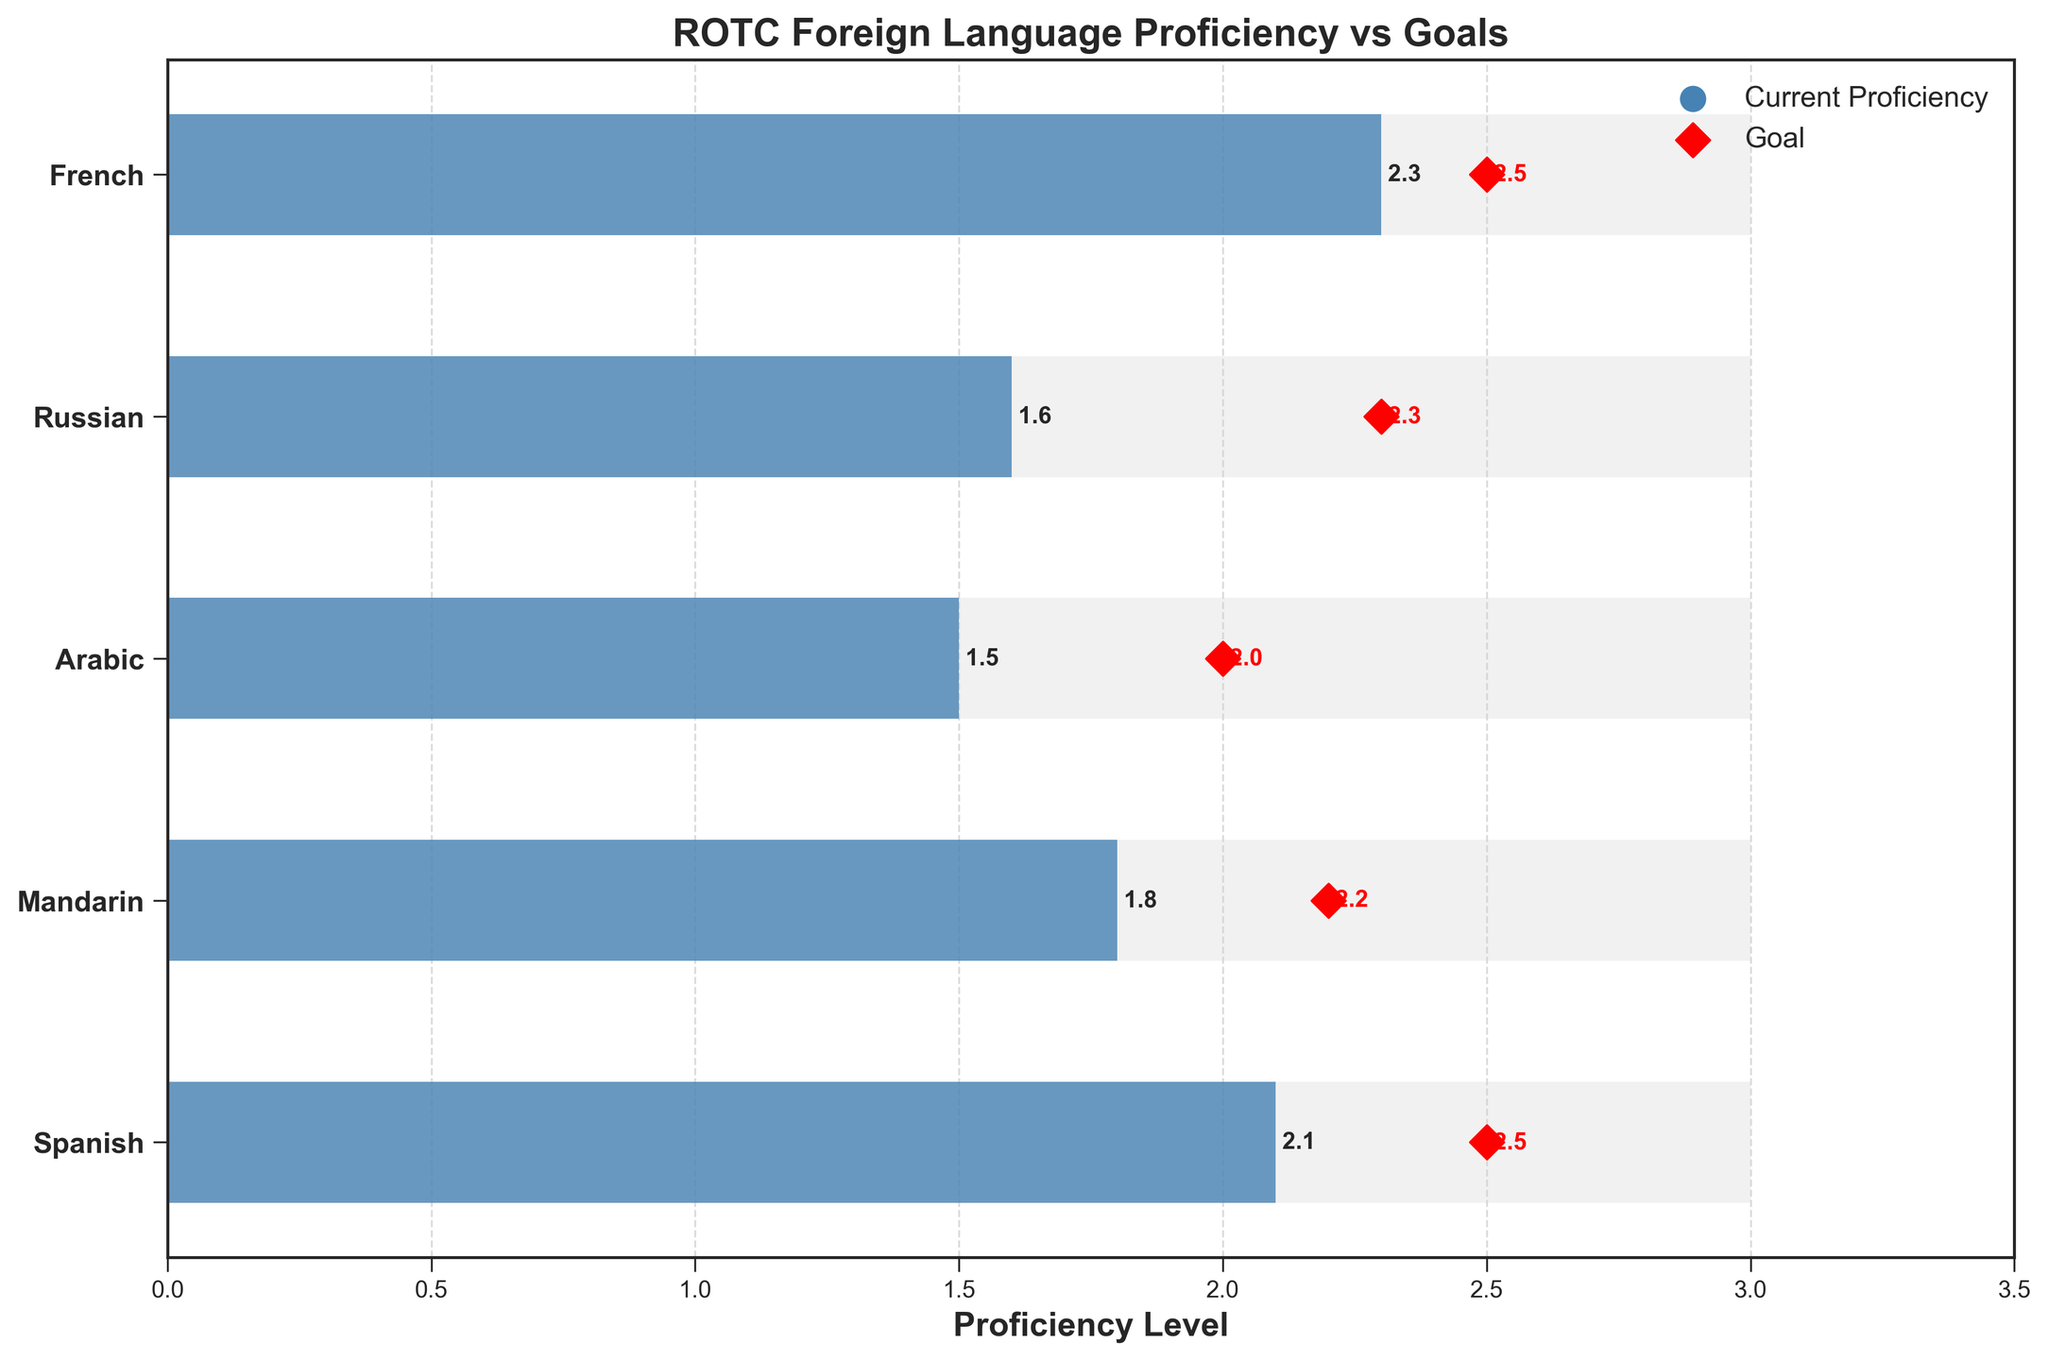Which language has the highest current proficiency level? To find the language with the highest current proficiency level, observe the bars that represent "Current Proficiency" and see which one extends the furthest to the right.
Answer: French Which language has the lowest goal proficiency level? To determine the language with the lowest proficiency goal, look at the red diamond markers on the horizontal axis and see which one is closest to the y-axis.
Answer: Arabic What is the difference between the maximum and current proficiency for Mandarin? Find the current proficiency and maximum for Mandarin, then subtract the current proficiency from the maximum (3.0 - 1.8).
Answer: 1.2 Which language is closest to reaching its goal proficiency level? Compare the red diamond (goal) positions with the blue bars (current proficiency) for each language, and identify which one has the smallest gap between the two.
Answer: French How many languages have a current proficiency level above 2.0? Check each language's current proficiency bar and count how many are above the 2.0 mark.
Answer: 2 Which language has the greatest gap between its goal and current proficiency levels? Calculate the difference between the goal and current proficiency for each language, and identify the one with the largest gap.
Answer: Russian What is the average goal proficiency level for all languages? Sum up the goal proficiency levels for all languages and divide by the number of languages. (2.5 + 2.2 + 2.0 + 2.3 + 2.5) / 5
Answer: 2.3 Between Russian and Spanish, which language has a higher goal proficiency level? Compare the goal proficiency levels for Russian and Spanish as represented by the red diamond markers.
Answer: Spanish Is any language's current proficiency equal to its goal proficiency? Check if any blue bar (current proficiency) aligns with its corresponding red diamond marker (goal proficiency).
Answer: No 